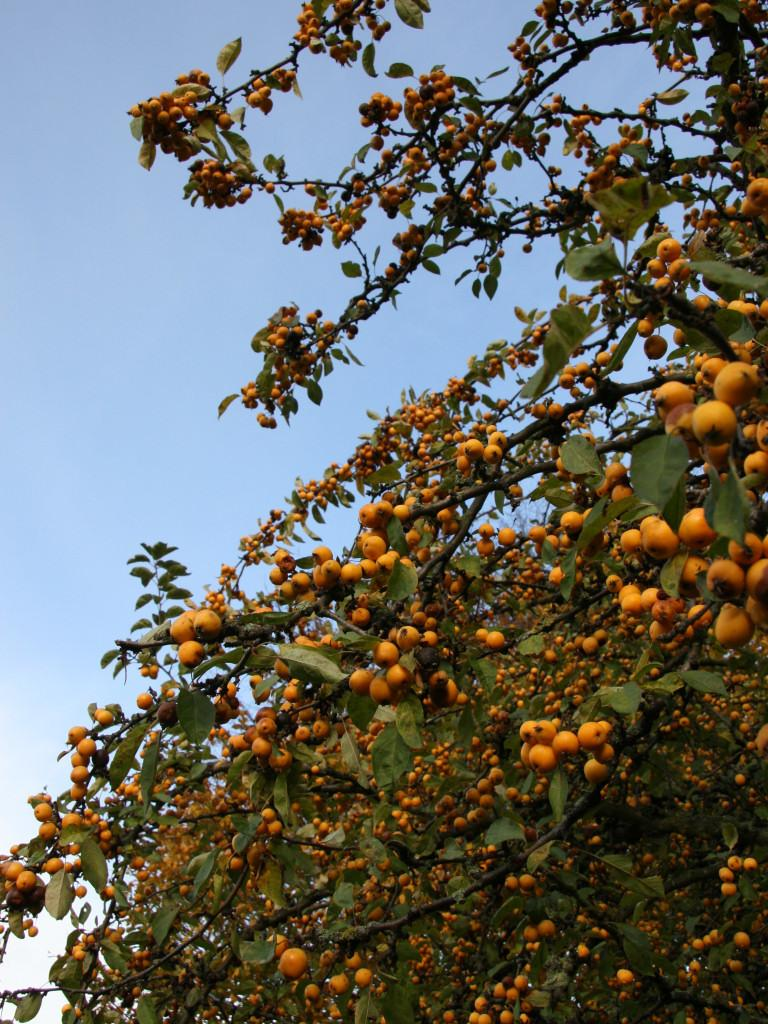What is the main object in the image? There is a branch in the image. What can be found on the branch? The branch contains leaves and fruits. What can be seen in the background of the image? There is a sky visible in the background of the image. How does the wind affect the veins of the leaves on the branch in the image? There are no veins visible on the leaves in the image, and the wind's effect cannot be determined from the image alone. 